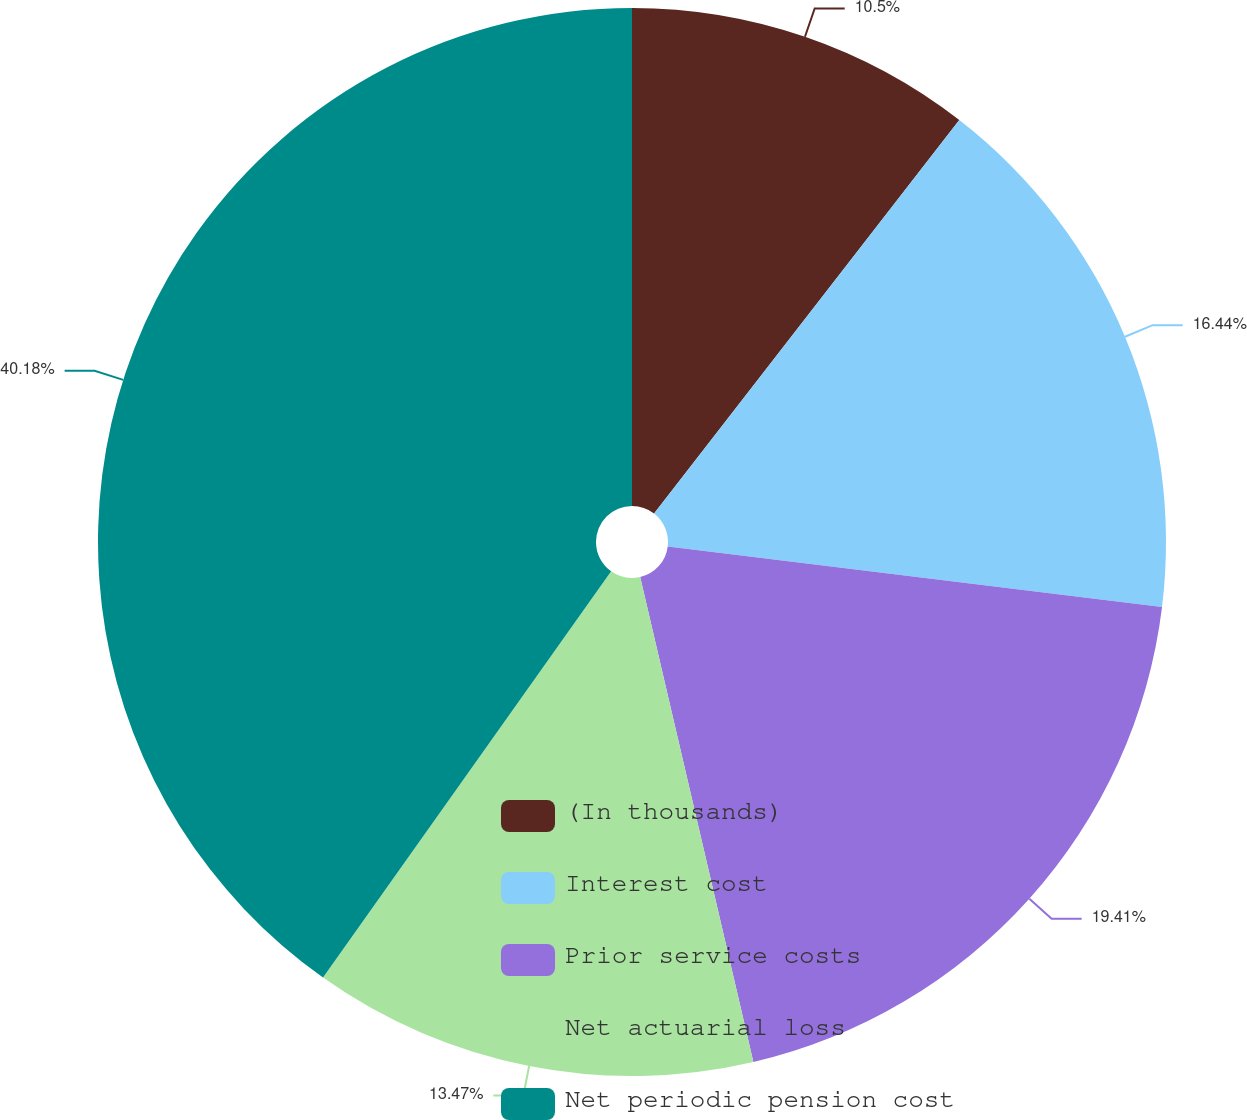<chart> <loc_0><loc_0><loc_500><loc_500><pie_chart><fcel>(In thousands)<fcel>Interest cost<fcel>Prior service costs<fcel>Net actuarial loss<fcel>Net periodic pension cost<nl><fcel>10.5%<fcel>16.44%<fcel>19.41%<fcel>13.47%<fcel>40.18%<nl></chart> 